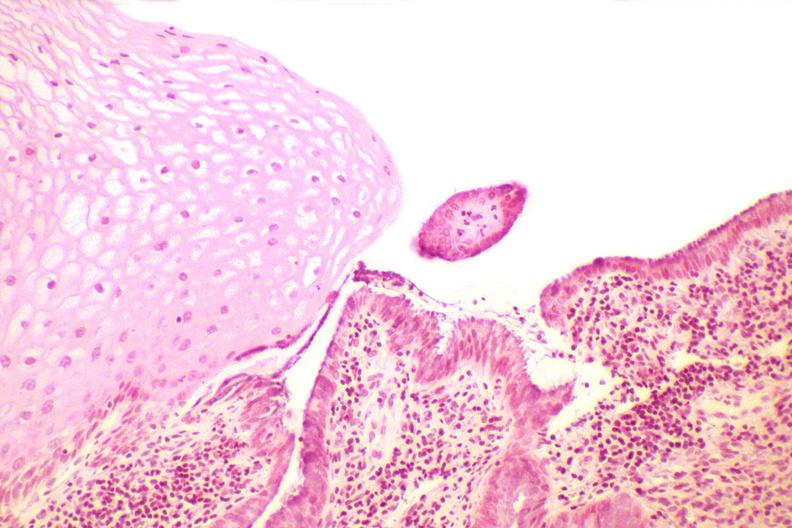what is present?
Answer the question using a single word or phrase. Female reproductive 